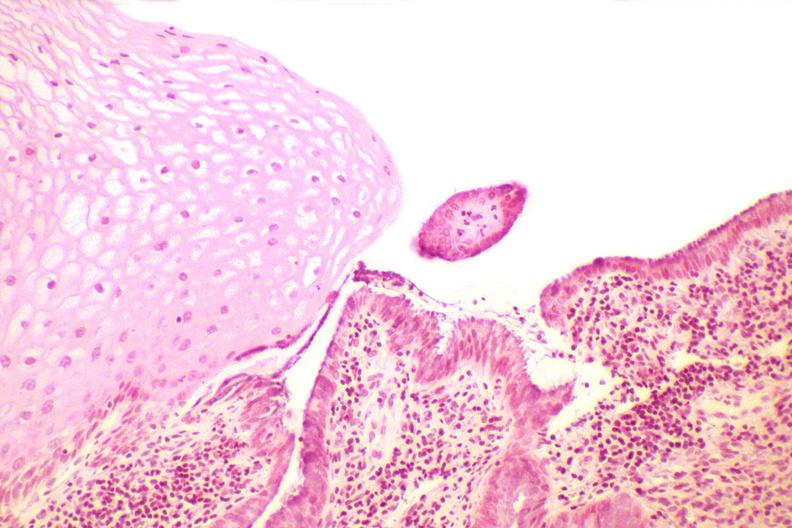what is present?
Answer the question using a single word or phrase. Female reproductive 